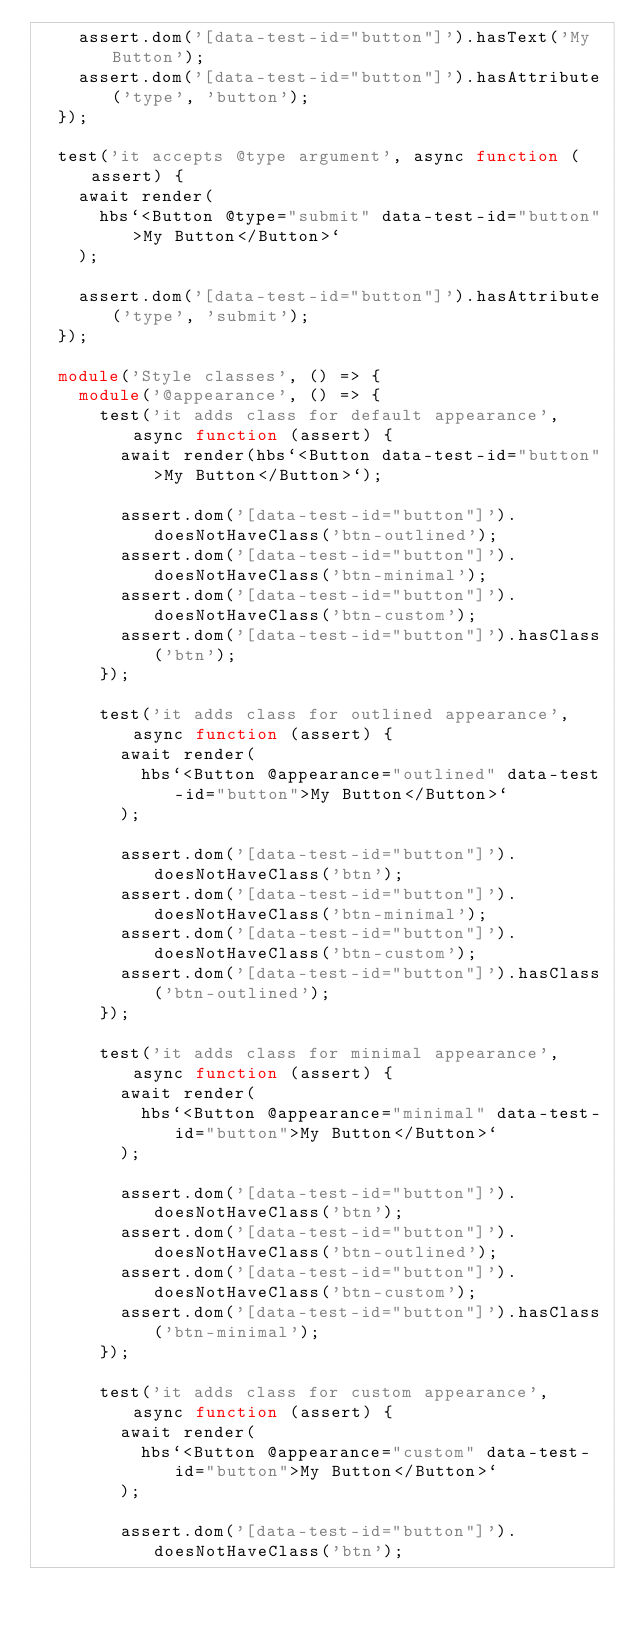<code> <loc_0><loc_0><loc_500><loc_500><_TypeScript_>    assert.dom('[data-test-id="button"]').hasText('My Button');
    assert.dom('[data-test-id="button"]').hasAttribute('type', 'button');
  });

  test('it accepts @type argument', async function (assert) {
    await render(
      hbs`<Button @type="submit" data-test-id="button">My Button</Button>`
    );

    assert.dom('[data-test-id="button"]').hasAttribute('type', 'submit');
  });

  module('Style classes', () => {
    module('@appearance', () => {
      test('it adds class for default appearance', async function (assert) {
        await render(hbs`<Button data-test-id="button">My Button</Button>`);

        assert.dom('[data-test-id="button"]').doesNotHaveClass('btn-outlined');
        assert.dom('[data-test-id="button"]').doesNotHaveClass('btn-minimal');
        assert.dom('[data-test-id="button"]').doesNotHaveClass('btn-custom');
        assert.dom('[data-test-id="button"]').hasClass('btn');
      });

      test('it adds class for outlined appearance', async function (assert) {
        await render(
          hbs`<Button @appearance="outlined" data-test-id="button">My Button</Button>`
        );

        assert.dom('[data-test-id="button"]').doesNotHaveClass('btn');
        assert.dom('[data-test-id="button"]').doesNotHaveClass('btn-minimal');
        assert.dom('[data-test-id="button"]').doesNotHaveClass('btn-custom');
        assert.dom('[data-test-id="button"]').hasClass('btn-outlined');
      });

      test('it adds class for minimal appearance', async function (assert) {
        await render(
          hbs`<Button @appearance="minimal" data-test-id="button">My Button</Button>`
        );

        assert.dom('[data-test-id="button"]').doesNotHaveClass('btn');
        assert.dom('[data-test-id="button"]').doesNotHaveClass('btn-outlined');
        assert.dom('[data-test-id="button"]').doesNotHaveClass('btn-custom');
        assert.dom('[data-test-id="button"]').hasClass('btn-minimal');
      });

      test('it adds class for custom appearance', async function (assert) {
        await render(
          hbs`<Button @appearance="custom" data-test-id="button">My Button</Button>`
        );

        assert.dom('[data-test-id="button"]').doesNotHaveClass('btn');</code> 